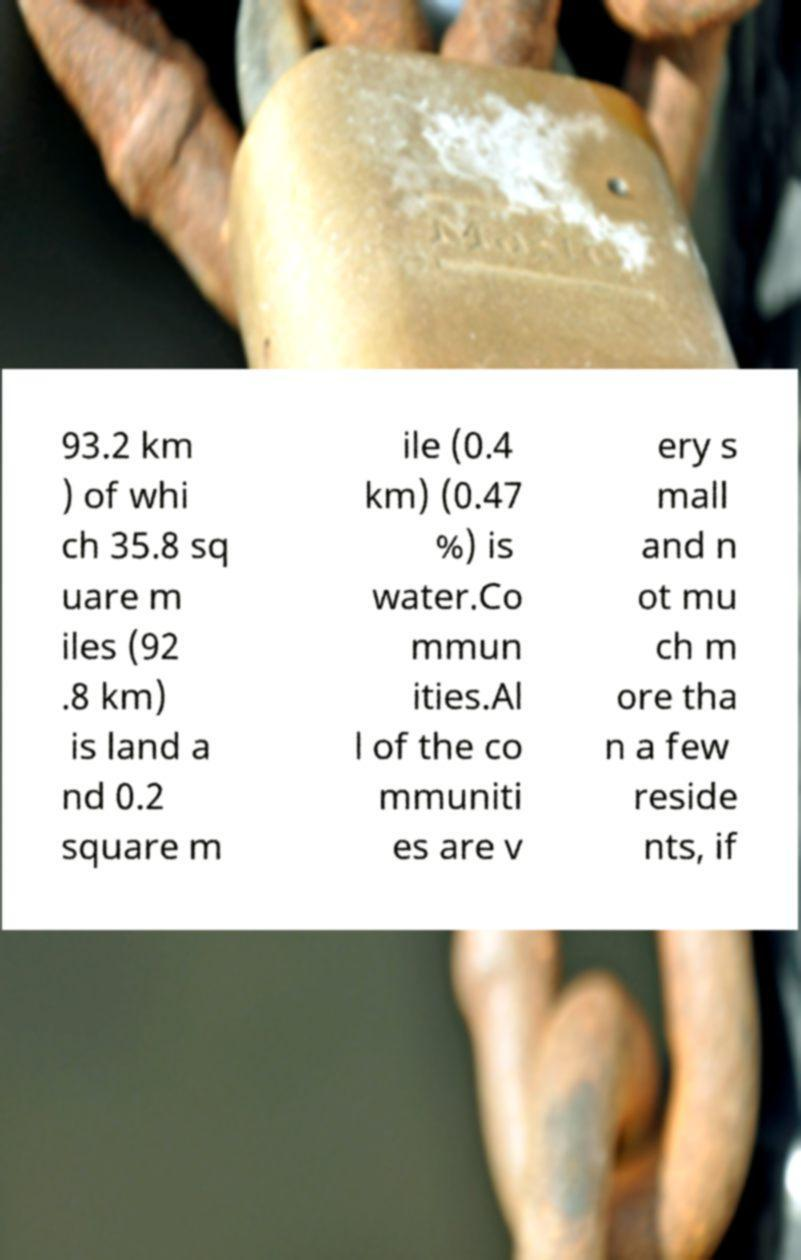What messages or text are displayed in this image? I need them in a readable, typed format. 93.2 km ) of whi ch 35.8 sq uare m iles (92 .8 km) is land a nd 0.2 square m ile (0.4 km) (0.47 %) is water.Co mmun ities.Al l of the co mmuniti es are v ery s mall and n ot mu ch m ore tha n a few reside nts, if 